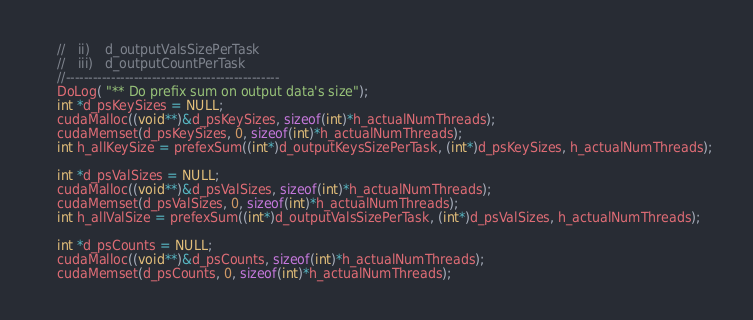<code> <loc_0><loc_0><loc_500><loc_500><_Cuda_>	//	 ii)	d_outputValsSizePerTask
	//	 iii)	d_outputCountPerTask
	//-----------------------------------------------
	DoLog( "** Do prefix sum on output data's size");
	int *d_psKeySizes = NULL;
	cudaMalloc((void**)&d_psKeySizes, sizeof(int)*h_actualNumThreads);
	cudaMemset(d_psKeySizes, 0, sizeof(int)*h_actualNumThreads);
	int h_allKeySize = prefexSum((int*)d_outputKeysSizePerTask, (int*)d_psKeySizes, h_actualNumThreads);

	int *d_psValSizes = NULL;
	cudaMalloc((void**)&d_psValSizes, sizeof(int)*h_actualNumThreads);
	cudaMemset(d_psValSizes, 0, sizeof(int)*h_actualNumThreads);
	int h_allValSize = prefexSum((int*)d_outputValsSizePerTask, (int*)d_psValSizes, h_actualNumThreads);

	int *d_psCounts = NULL;
	cudaMalloc((void**)&d_psCounts, sizeof(int)*h_actualNumThreads);
	cudaMemset(d_psCounts, 0, sizeof(int)*h_actualNumThreads);</code> 